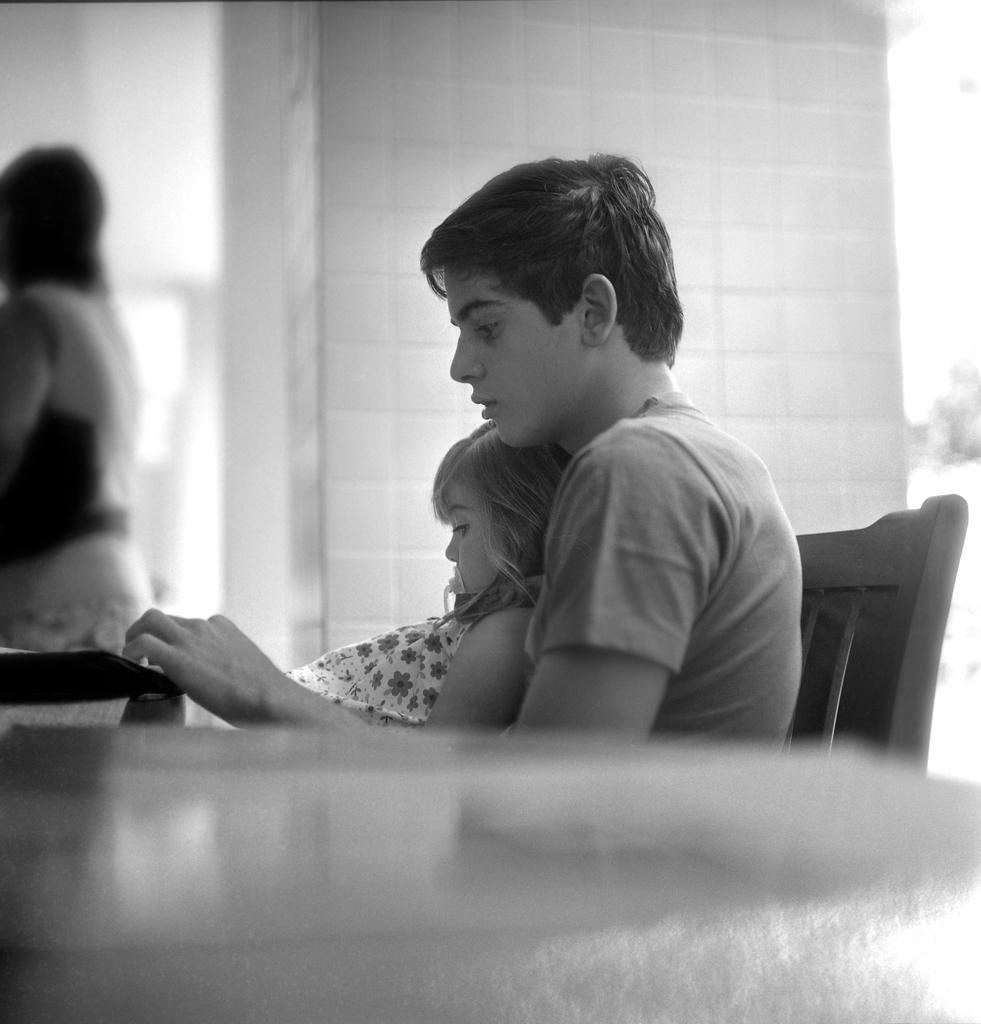Who are the two people in the image? There is a boy and a girl in the image. What are the boy and girl doing in the image? The boy and girl are sitting in a chair. What are they looking at? The boy and girl are looking at something. How many cherries are on the mailbox in the image? There is no mailbox or cherries present in the image. 